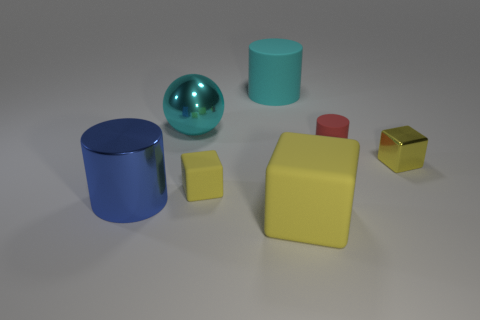There is a red matte thing that is the same shape as the big blue object; what is its size?
Keep it short and to the point. Small. There is a rubber thing that is left of the large cyan rubber thing; does it have the same color as the metallic block?
Offer a terse response. Yes. How big is the cyan object behind the ball?
Your answer should be compact. Large. There is a metallic object in front of the tiny cube that is right of the small red thing; what is its shape?
Provide a short and direct response. Cylinder. There is another matte object that is the same shape as the tiny yellow matte thing; what is its color?
Offer a terse response. Yellow. Does the yellow cube that is in front of the blue metal cylinder have the same size as the large blue metal cylinder?
Offer a terse response. Yes. What shape is the big matte object that is the same color as the small metal thing?
Give a very brief answer. Cube. What number of large cubes have the same material as the tiny cylinder?
Offer a very short reply. 1. What material is the tiny block to the left of the metal object that is on the right side of the large yellow matte cube that is to the left of the red rubber cylinder?
Give a very brief answer. Rubber. The cube in front of the yellow thing to the left of the large yellow matte cube is what color?
Your response must be concise. Yellow. 